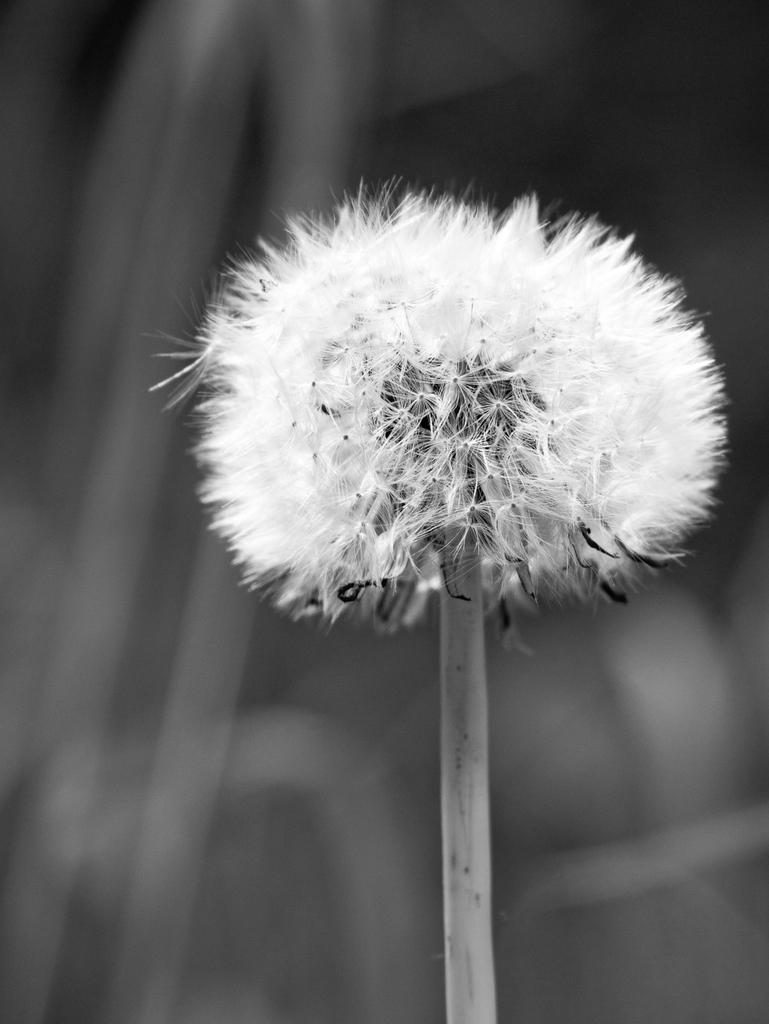How would you summarize this image in a sentence or two? In this picture we can see a stem with a flower and in the background it is blurry. 